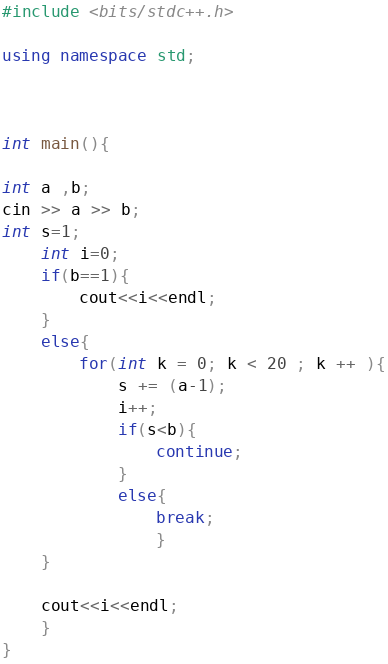Convert code to text. <code><loc_0><loc_0><loc_500><loc_500><_C++_>
#include <bits/stdc++.h>

using namespace std;



int main(){

int a ,b;
cin >> a >> b;
int s=1;
	int i=0;
	if(b==1){
		cout<<i<<endl;
	}
	else{
		for(int k = 0; k < 20 ; k ++ ){
			s += (a-1);
			i++;
			if(s<b){
				continue;
			}
			else{
				break;
				}
	}

	cout<<i<<endl;
	}
}
</code> 